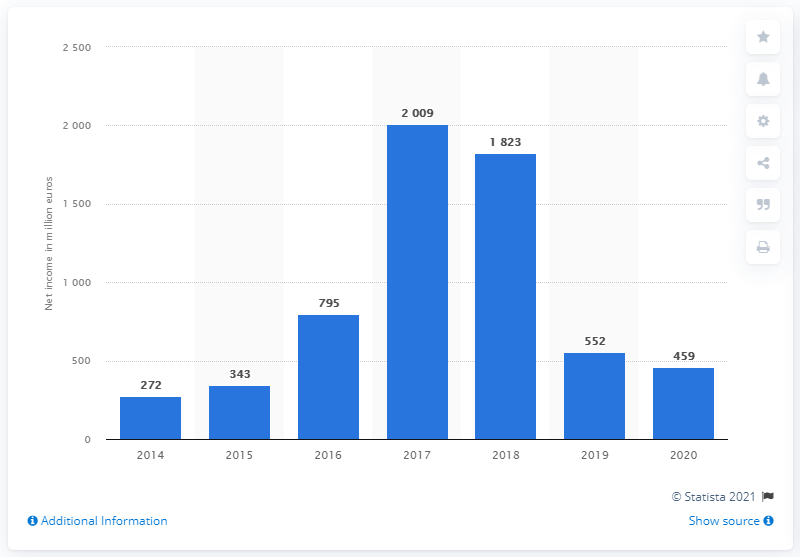List a handful of essential elements in this visual. In 2020, Covestro's net income was 459 million euros. 